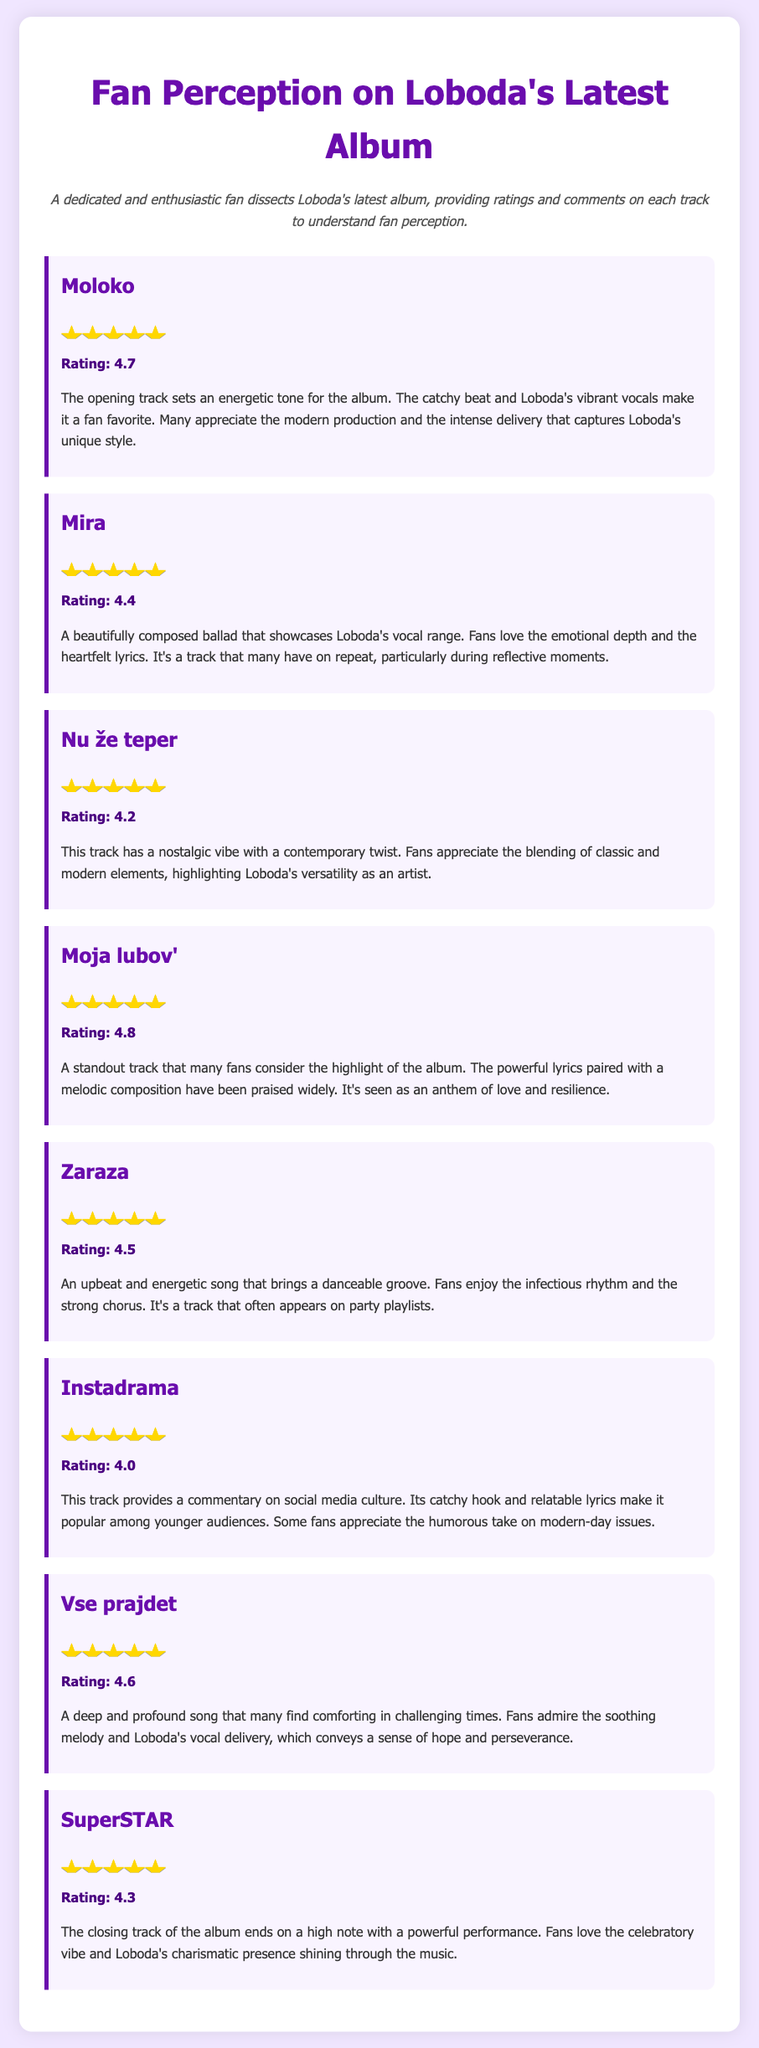What is the title of Loboda's latest album? The document contains an overview of fan perceptions about the latest album, but it does not explicitly mention its title.
Answer: Not specified How many tracks are rated in the survey? The survey features comments and ratings for eight tracks from Loboda's latest album.
Answer: Eight Which track has the highest rating? "Moja lubov'" has the highest rating of 4.8 according to the survey.
Answer: Moja lubov' What is the rating for the track "Mira"? The survey indicates that the track "Mira" has a rating of 4.4.
Answer: 4.4 What genre does the track "Instadrama" comment on? "Instadrama" provides commentary on social media culture as mentioned in the comments.
Answer: Social media culture Which track ends the album on a high note? The document states that the closing track of the album is "SuperSTAR," which ends on a high note.
Answer: SuperSTAR What emotional aspect does the track "Vse prajdet" convey? According to the comments, "Vse prajdet" is described as conveying a sense of hope and perseverance.
Answer: Hope and perseverance What is the overall sentiment expressed by fans about "Nu že teper"? Fans appreciate the blending of classic and modern elements in "Nu že teper," highlighting Loboda's versatility.
Answer: Versatility 